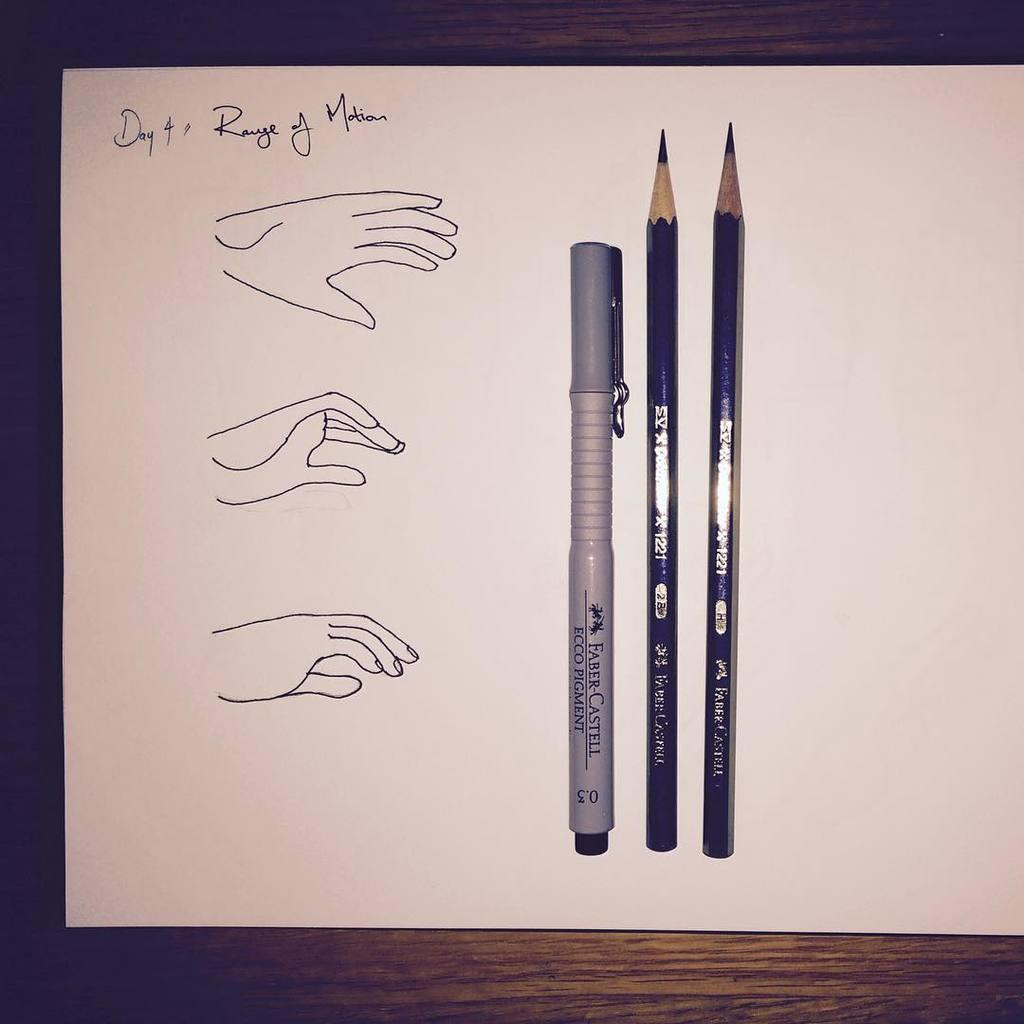How many writing instruments can be seen in the image? There are two pencils and a pen in the image. What is the color of the paper on which the objects are placed? The paper is white in color. What is depicted in the sketch on the paper? There is a sketch of hands in the image. What is written on the paper? Something is written on the paper, but the specific content is not mentioned in the facts. What is the color of the surface on which the paper is placed? The paper is on a brown color surface. What type of cake is being served on the net in the image? There is no cake or net present in the image. What verse is being recited by the hands in the sketch? The facts do not mention any verse being recited by the hands in the sketch. 